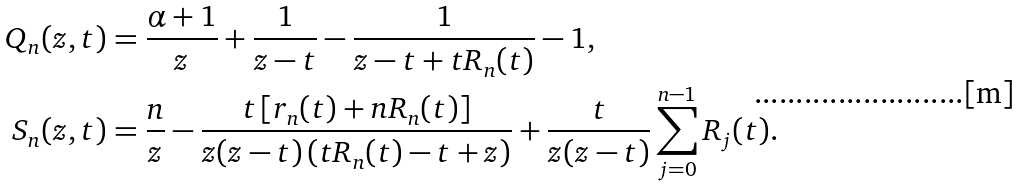Convert formula to latex. <formula><loc_0><loc_0><loc_500><loc_500>Q _ { n } ( z , t ) & = \frac { \alpha + 1 } { z } + \frac { 1 } { z - t } - \frac { 1 } { z - t + t R _ { n } ( t ) } - 1 , \\ S _ { n } ( z , t ) & = \frac { n } { z } - \frac { t \left [ r _ { n } ( t ) + n R _ { n } ( t ) \right ] } { z ( z - t ) \left ( t R _ { n } ( t ) - t + z \right ) } + \frac { t } { z ( z - t ) } \sum _ { j = 0 } ^ { n - 1 } R _ { j } ( t ) .</formula> 